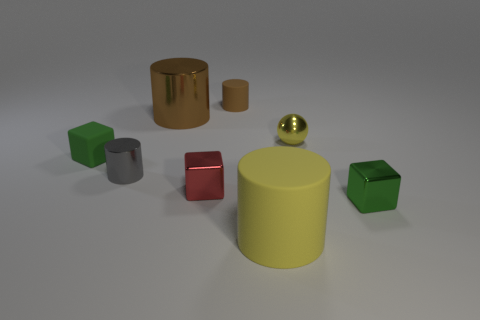Subtract all gray metallic cylinders. How many cylinders are left? 3 Subtract all green spheres. How many green blocks are left? 2 Subtract 2 cylinders. How many cylinders are left? 2 Subtract all yellow cylinders. How many cylinders are left? 3 Add 1 small brown objects. How many objects exist? 9 Subtract all balls. How many objects are left? 7 Subtract all purple cubes. Subtract all blue cylinders. How many cubes are left? 3 Add 5 brown metal cylinders. How many brown metal cylinders are left? 6 Add 8 tiny yellow balls. How many tiny yellow balls exist? 9 Subtract 0 purple cylinders. How many objects are left? 8 